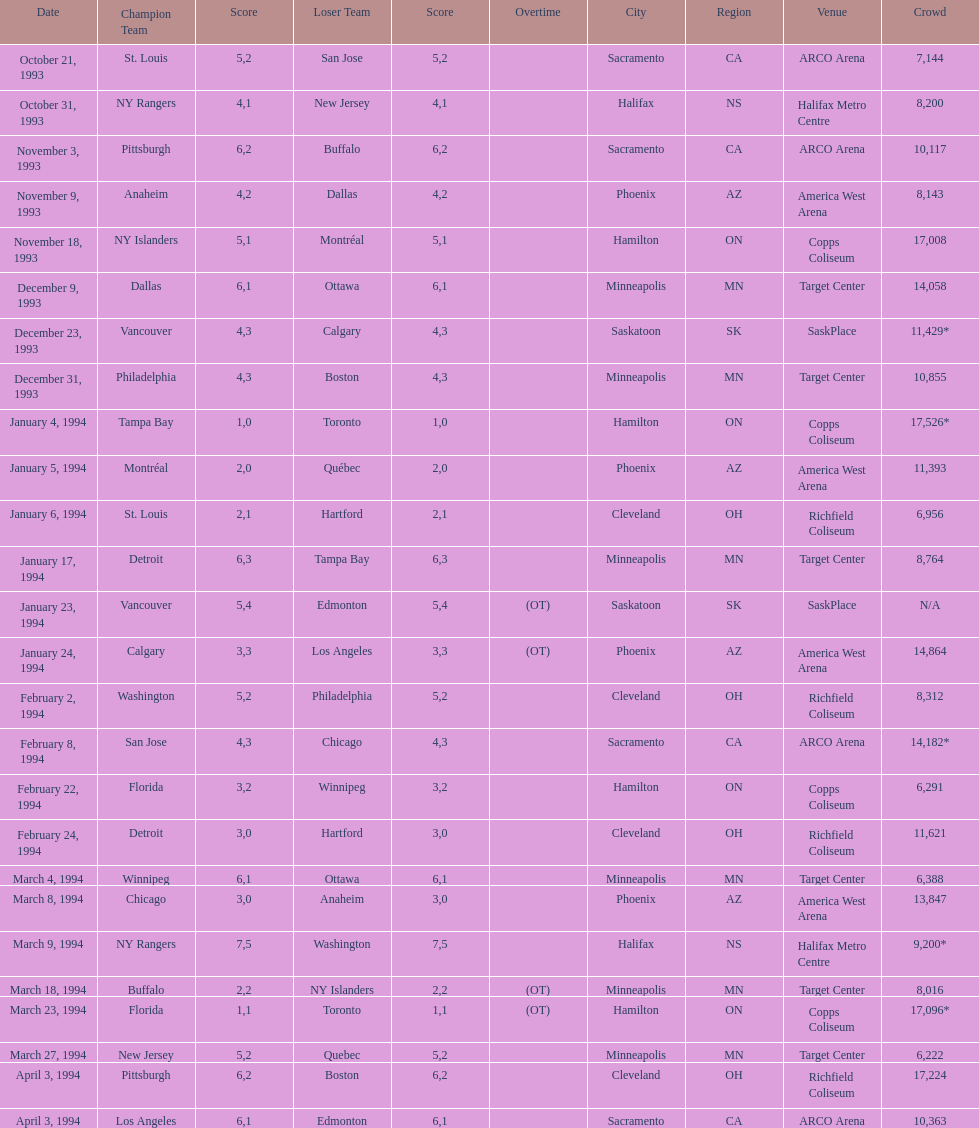Could you help me parse every detail presented in this table? {'header': ['Date', 'Champion Team', 'Score', 'Loser Team', 'Score', 'Overtime', 'City', 'Region', 'Venue', 'Crowd'], 'rows': [['October 21, 1993', 'St. Louis', '5', 'San Jose', '2', '', 'Sacramento', 'CA', 'ARCO Arena', '7,144'], ['October 31, 1993', 'NY Rangers', '4', 'New Jersey', '1', '', 'Halifax', 'NS', 'Halifax Metro Centre', '8,200'], ['November 3, 1993', 'Pittsburgh', '6', 'Buffalo', '2', '', 'Sacramento', 'CA', 'ARCO Arena', '10,117'], ['November 9, 1993', 'Anaheim', '4', 'Dallas', '2', '', 'Phoenix', 'AZ', 'America West Arena', '8,143'], ['November 18, 1993', 'NY Islanders', '5', 'Montréal', '1', '', 'Hamilton', 'ON', 'Copps Coliseum', '17,008'], ['December 9, 1993', 'Dallas', '6', 'Ottawa', '1', '', 'Minneapolis', 'MN', 'Target Center', '14,058'], ['December 23, 1993', 'Vancouver', '4', 'Calgary', '3', '', 'Saskatoon', 'SK', 'SaskPlace', '11,429*'], ['December 31, 1993', 'Philadelphia', '4', 'Boston', '3', '', 'Minneapolis', 'MN', 'Target Center', '10,855'], ['January 4, 1994', 'Tampa Bay', '1', 'Toronto', '0', '', 'Hamilton', 'ON', 'Copps Coliseum', '17,526*'], ['January 5, 1994', 'Montréal', '2', 'Québec', '0', '', 'Phoenix', 'AZ', 'America West Arena', '11,393'], ['January 6, 1994', 'St. Louis', '2', 'Hartford', '1', '', 'Cleveland', 'OH', 'Richfield Coliseum', '6,956'], ['January 17, 1994', 'Detroit', '6', 'Tampa Bay', '3', '', 'Minneapolis', 'MN', 'Target Center', '8,764'], ['January 23, 1994', 'Vancouver', '5', 'Edmonton', '4', '(OT)', 'Saskatoon', 'SK', 'SaskPlace', 'N/A'], ['January 24, 1994', 'Calgary', '3', 'Los Angeles', '3', '(OT)', 'Phoenix', 'AZ', 'America West Arena', '14,864'], ['February 2, 1994', 'Washington', '5', 'Philadelphia', '2', '', 'Cleveland', 'OH', 'Richfield Coliseum', '8,312'], ['February 8, 1994', 'San Jose', '4', 'Chicago', '3', '', 'Sacramento', 'CA', 'ARCO Arena', '14,182*'], ['February 22, 1994', 'Florida', '3', 'Winnipeg', '2', '', 'Hamilton', 'ON', 'Copps Coliseum', '6,291'], ['February 24, 1994', 'Detroit', '3', 'Hartford', '0', '', 'Cleveland', 'OH', 'Richfield Coliseum', '11,621'], ['March 4, 1994', 'Winnipeg', '6', 'Ottawa', '1', '', 'Minneapolis', 'MN', 'Target Center', '6,388'], ['March 8, 1994', 'Chicago', '3', 'Anaheim', '0', '', 'Phoenix', 'AZ', 'America West Arena', '13,847'], ['March 9, 1994', 'NY Rangers', '7', 'Washington', '5', '', 'Halifax', 'NS', 'Halifax Metro Centre', '9,200*'], ['March 18, 1994', 'Buffalo', '2', 'NY Islanders', '2', '(OT)', 'Minneapolis', 'MN', 'Target Center', '8,016'], ['March 23, 1994', 'Florida', '1', 'Toronto', '1', '(OT)', 'Hamilton', 'ON', 'Copps Coliseum', '17,096*'], ['March 27, 1994', 'New Jersey', '5', 'Quebec', '2', '', 'Minneapolis', 'MN', 'Target Center', '6,222'], ['April 3, 1994', 'Pittsburgh', '6', 'Boston', '2', '', 'Cleveland', 'OH', 'Richfield Coliseum', '17,224'], ['April 3, 1994', 'Los Angeles', '6', 'Edmonton', '1', '', 'Sacramento', 'CA', 'ARCO Arena', '10,363']]} How many neutral site games resulted in overtime (ot)? 4. 